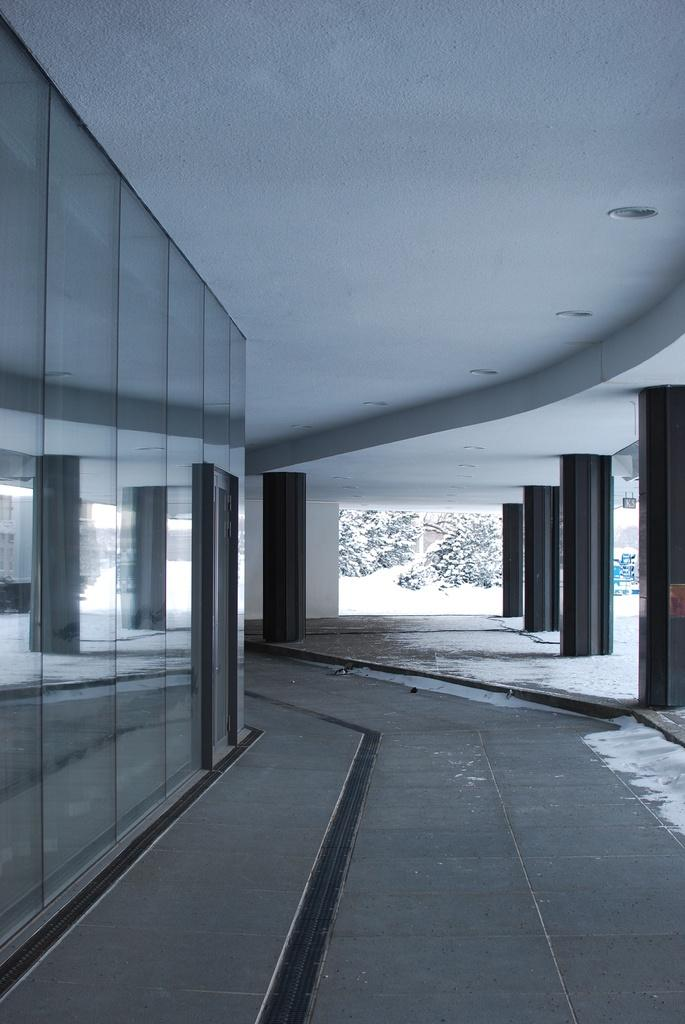What type of space is depicted in the image? There is a corridor in the image. What can be seen outside the corridor? There are trees visible in the image. What is the surface underfoot in the corridor? The floor is visible in the image. What objects are present in the corridor that might reflect light or images? There are mirrors in the image. What type of drug is being sold in the image? There is no indication of any drug being sold or present in the image. Can you see any monkeys in the image? There are no monkeys present in the image. 